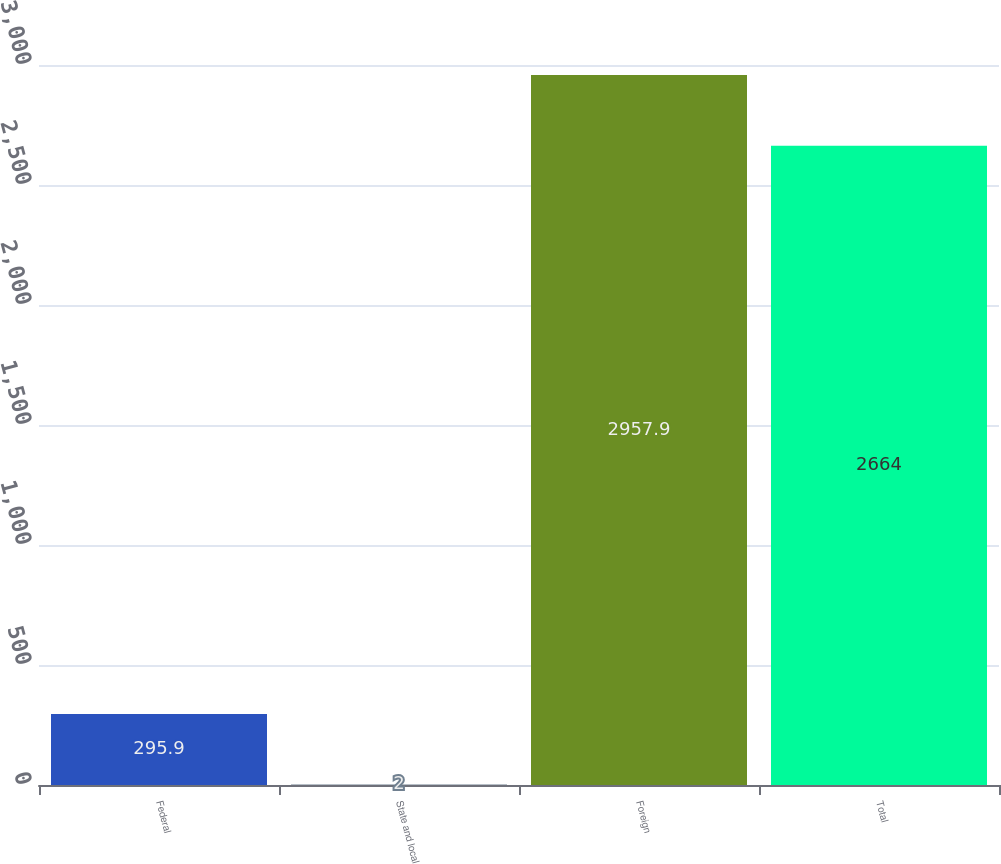<chart> <loc_0><loc_0><loc_500><loc_500><bar_chart><fcel>Federal<fcel>State and local<fcel>Foreign<fcel>Total<nl><fcel>295.9<fcel>2<fcel>2957.9<fcel>2664<nl></chart> 